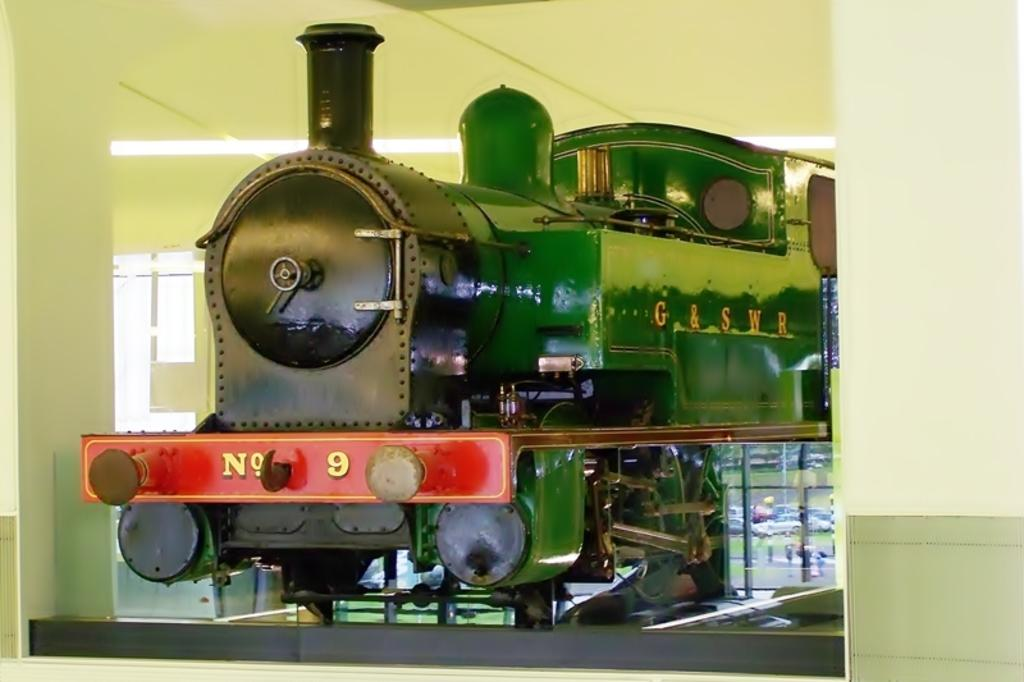What is the main subject of the image? The main subject of the image is a train engine. How is the train engine presented in the image? The train engine is placed in a display. What can be seen in the background of the image? There is a glass window and a wall in the background of the image. What type of ball is being used by the lawyer in the image? There is no lawyer or ball present in the image; it features a train engine in a display with a glass window and a wall in the background. 